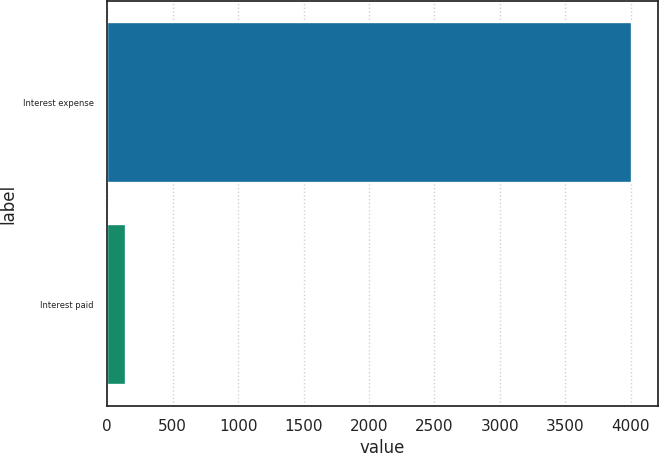Convert chart to OTSL. <chart><loc_0><loc_0><loc_500><loc_500><bar_chart><fcel>Interest expense<fcel>Interest paid<nl><fcel>4006<fcel>144<nl></chart> 